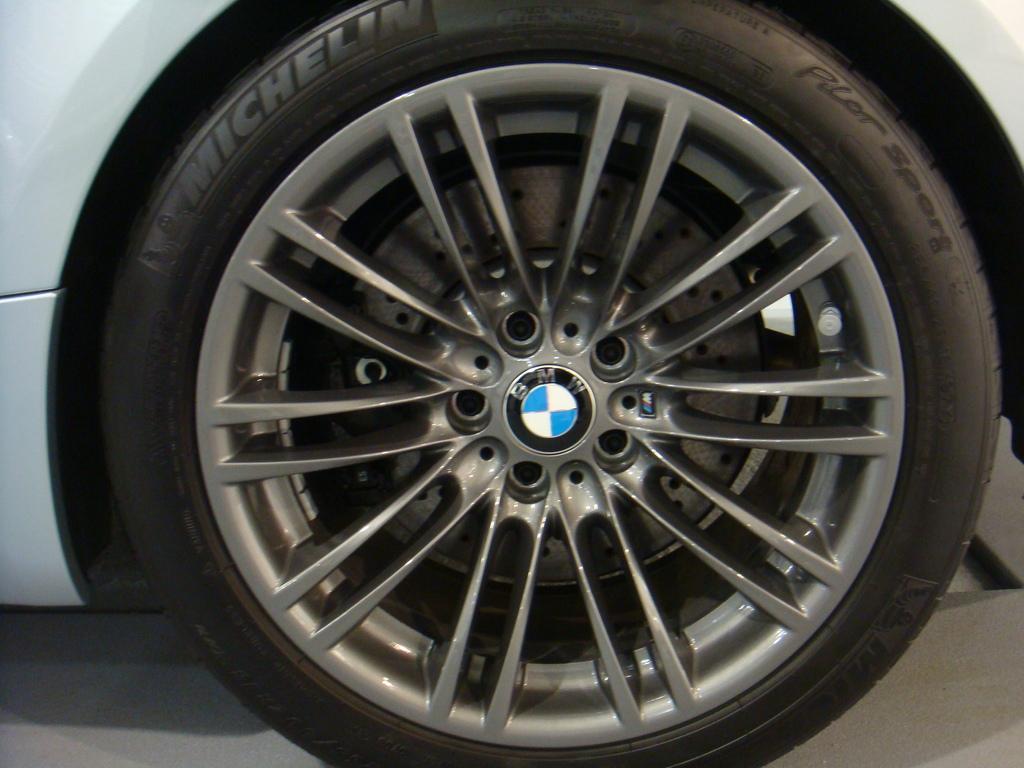In one or two sentences, can you explain what this image depicts? In this picture we can see a car wheel. On the tire we can see the text. In the center of the image we can see a logo and text. At the bottom of the image we can see the floor. 